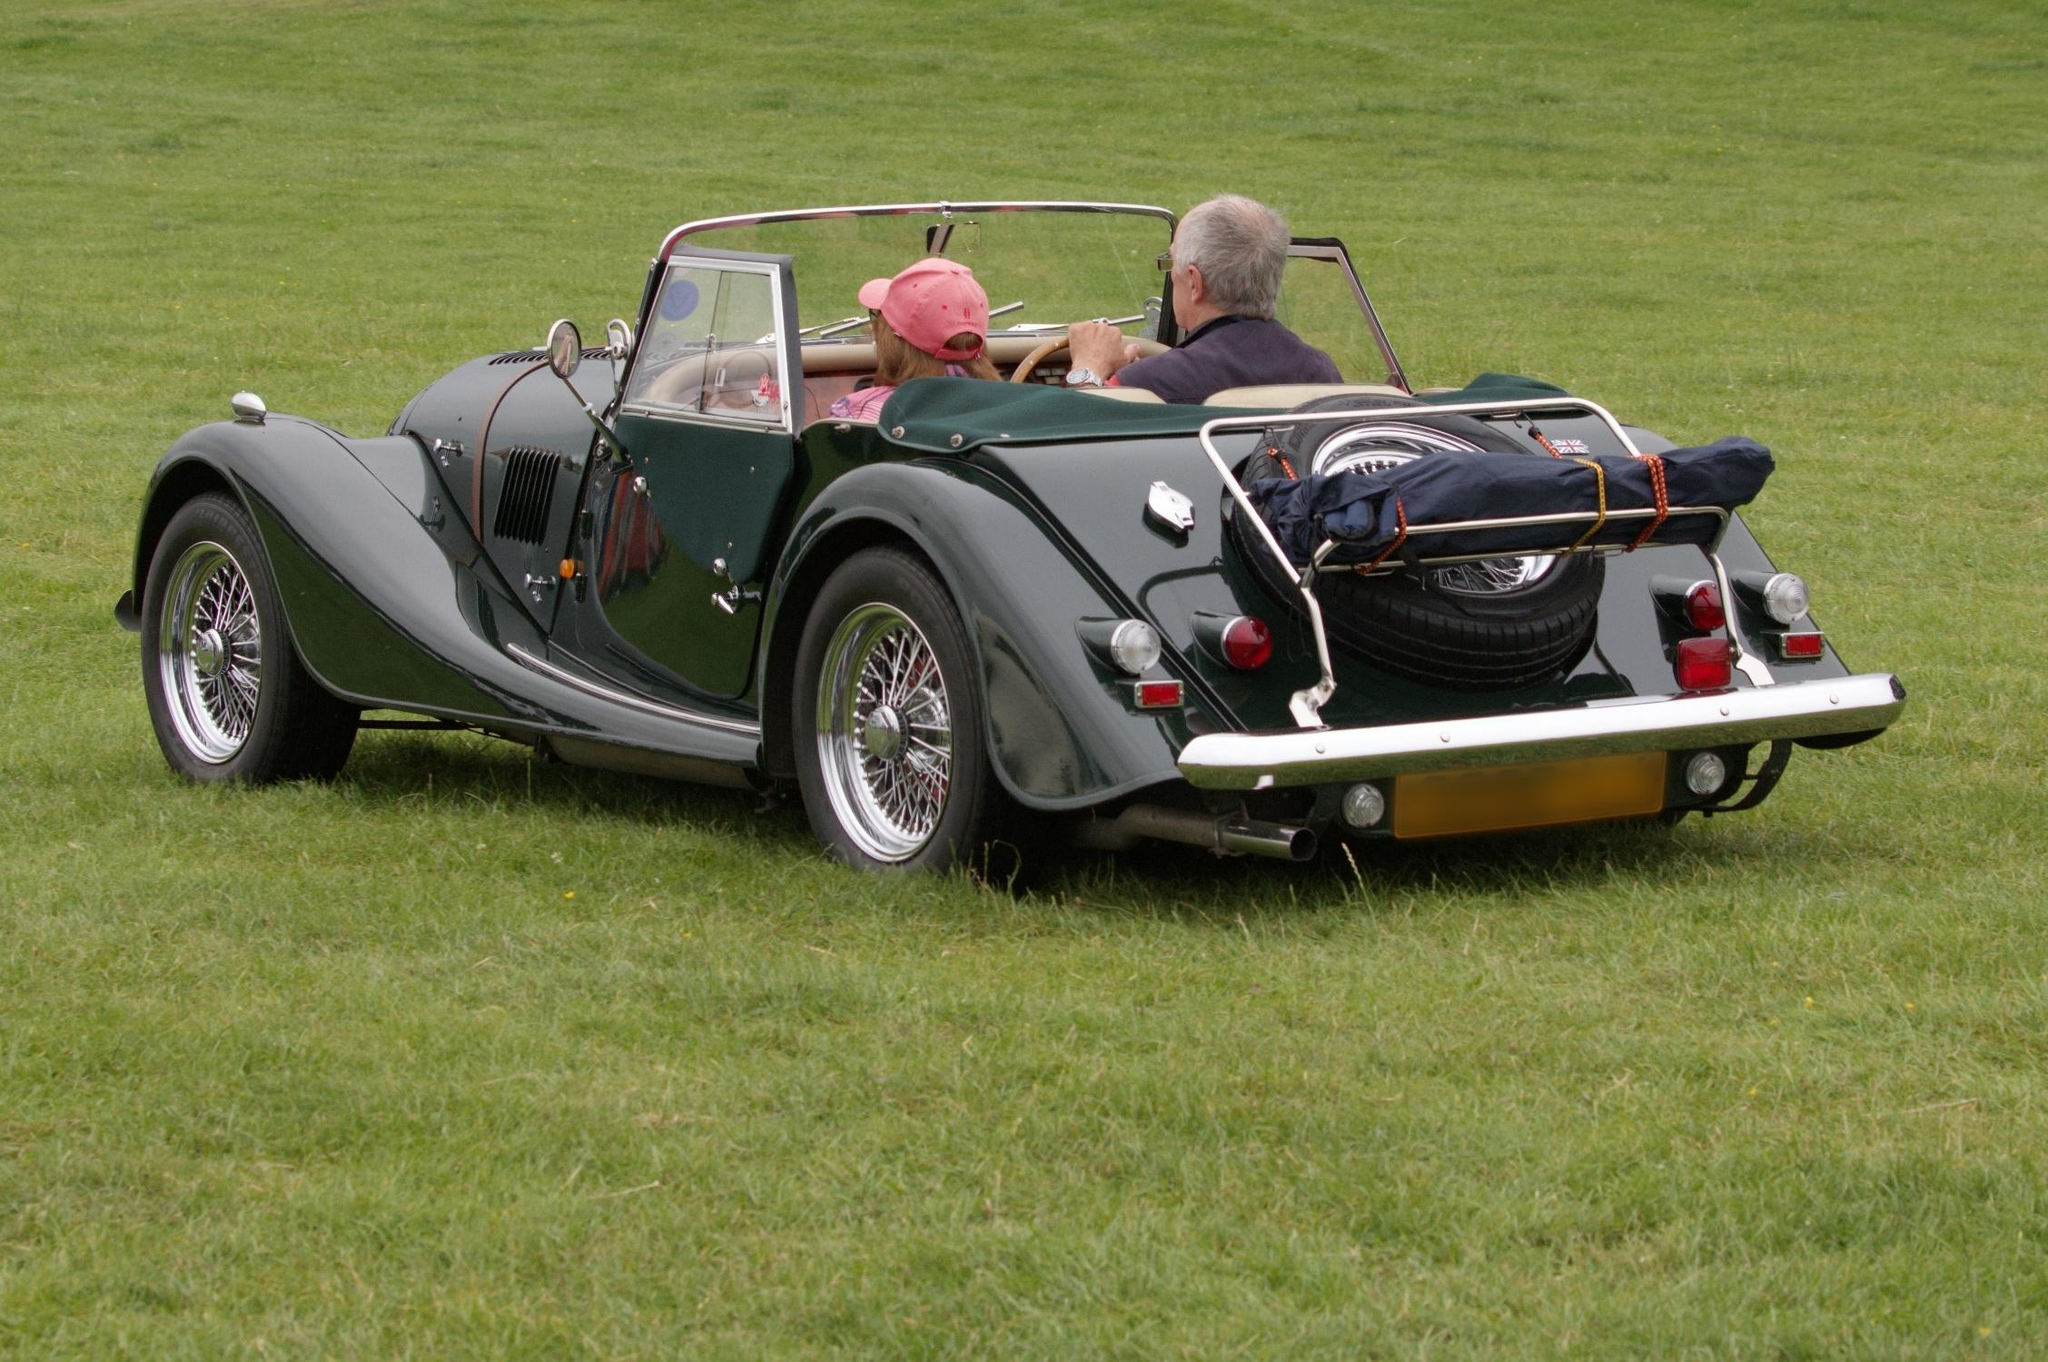The vintage car looks stunning! Can you tell me more about its potential history and significance? This vintage car, with its classic design and immaculate condition, likely holds significant historical value. Vehicles like this one were often crafted in the early to mid-20th century, a period marked by innovative automotive design and engineering. This particular model, with its wire wheels and rear-mounted spare tire, suggests it may be from the 1930s or 1940s. These cars were not just modes of transportation, but symbols of style and status, often featured in timeless films and cherished as collector's items today. The care given to its maintenance indicates the owner's appreciation for its heritage and a commitment to preserving a piece of automotive history. It must feel amazing driving such a car! How does it compare to modern vehicles in terms of performance and comfort? Driving a vintage car is a distinct experience compared to modern vehicles. While it may lack the advanced technology, comfort features, and seamless performance of contemporary cars, it offers a unique connection to the past. Vintage cars often have manual transmissions, less powerful engines, and basic suspension systems, which can make for a more engaging and hands-on driving experience. The charm lies in their simplicity and the nostalgia they evoke. Comfort might be more basic, with less cushioning and fewer amenities, but the joy comes from the journey itself, the gentle roar of the engine, and the sheer beauty of the design. It's a testament to the era's craftsmanship and the love for the road. Imagine if this car had a magical history! What kind of adventures could this car have been a part of? Envision this: The vintage car once belonged to an explorer who traveled the world in pursuit of hidden treasures and ancient artifacts. It journeyed through bustling European cities, across the frozen tundras of Siberia, through the dense jungles of South America, and along the sun-kissed coasts of Australia. Each scratch and dent tells a story: evading bandits on narrow mountain passes, escaping through hidden routes in wartime France, navigating secretive paths known only to a select few. Passengers ranging from daring adventurers to secret agents have occupied its seats, forging alliances, and unearthing lost histories. Its trunk, at times, concealed so much more than luggage – from precious gemstones to ancient manuscripts. This car is not just a vehicle; it's a timeless traveler of secrets and sagas. 